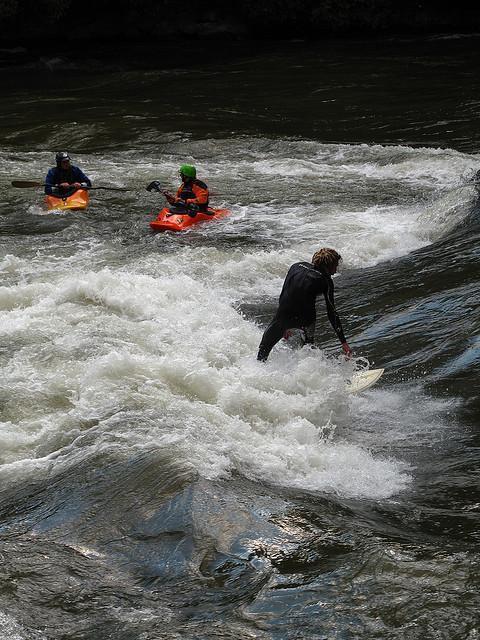What is the person to the far left sitting on?
Choose the correct response and explain in the format: 'Answer: answer
Rationale: rationale.'
Options: Bench, chair, cardboard box, boat. Answer: boat.
Rationale: The people on the left are inside of a raft floating. 